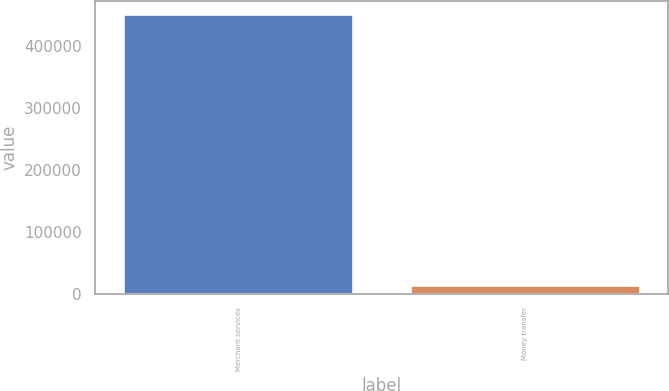Convert chart to OTSL. <chart><loc_0><loc_0><loc_500><loc_500><bar_chart><fcel>Merchant services<fcel>Money transfer<nl><fcel>449144<fcel>13682<nl></chart> 